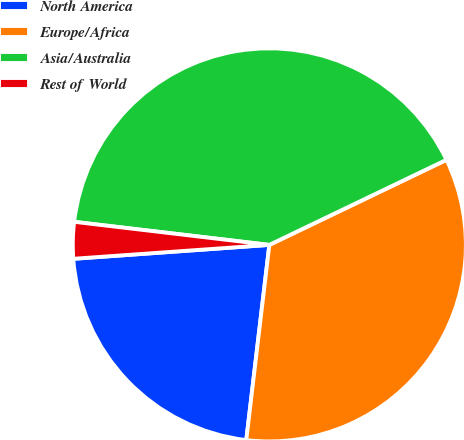<chart> <loc_0><loc_0><loc_500><loc_500><pie_chart><fcel>North America<fcel>Europe/Africa<fcel>Asia/Australia<fcel>Rest of World<nl><fcel>22.0%<fcel>34.0%<fcel>41.0%<fcel>3.0%<nl></chart> 